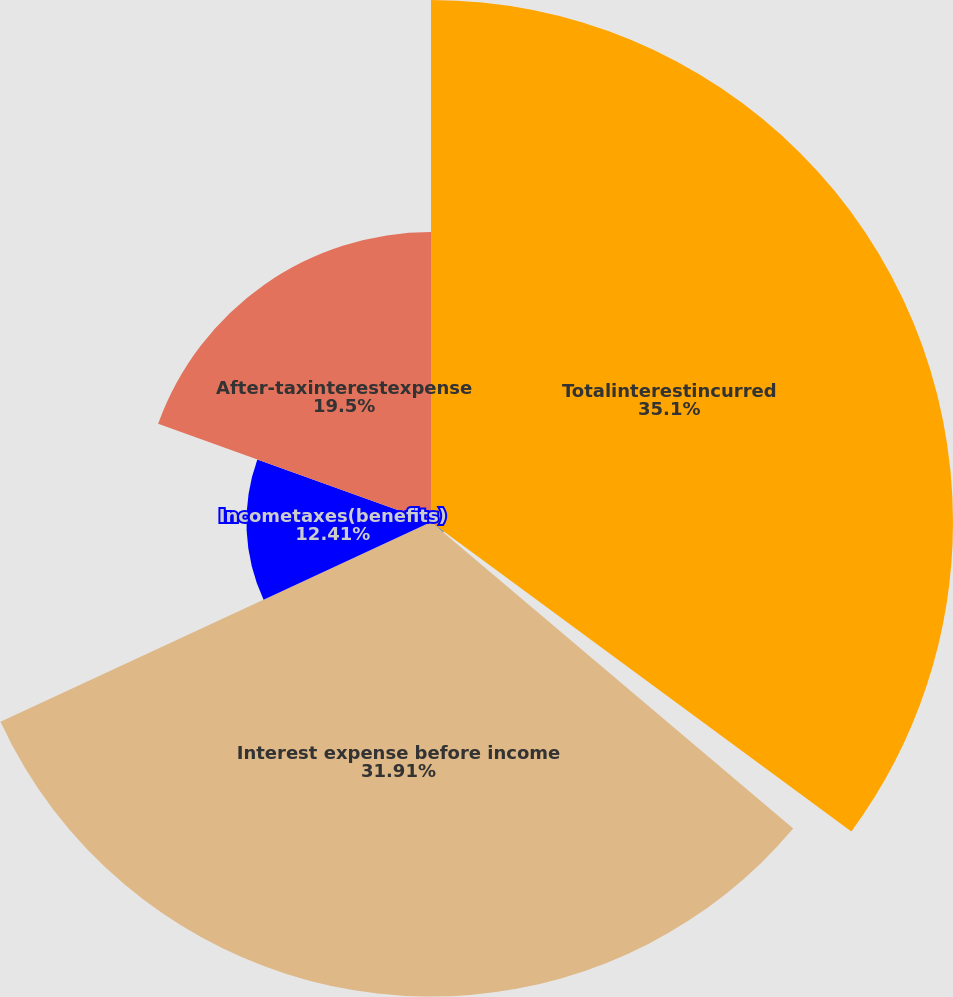Convert chart to OTSL. <chart><loc_0><loc_0><loc_500><loc_500><pie_chart><fcel>Totalinterestincurred<fcel>Capitalizedinterest<fcel>Interest expense before income<fcel>Incometaxes(benefits)<fcel>After-taxinterestexpense<nl><fcel>35.1%<fcel>1.08%<fcel>31.91%<fcel>12.41%<fcel>19.5%<nl></chart> 